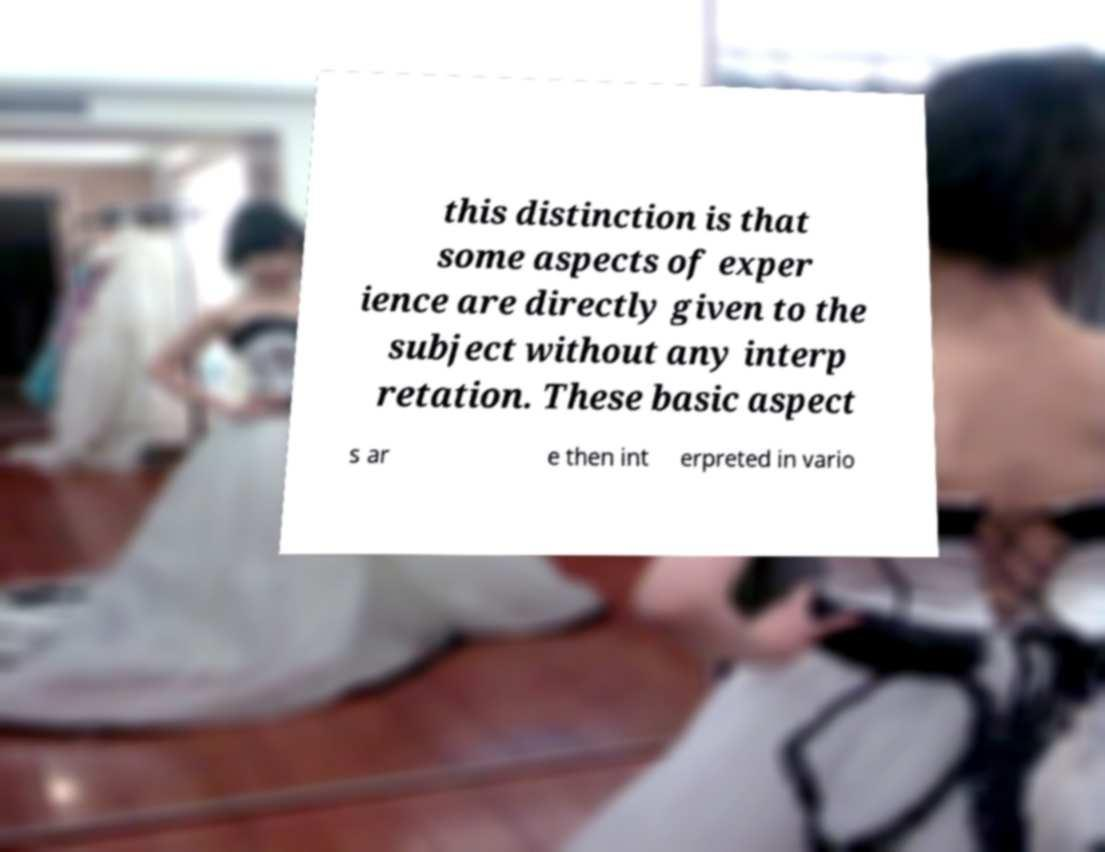I need the written content from this picture converted into text. Can you do that? this distinction is that some aspects of exper ience are directly given to the subject without any interp retation. These basic aspect s ar e then int erpreted in vario 